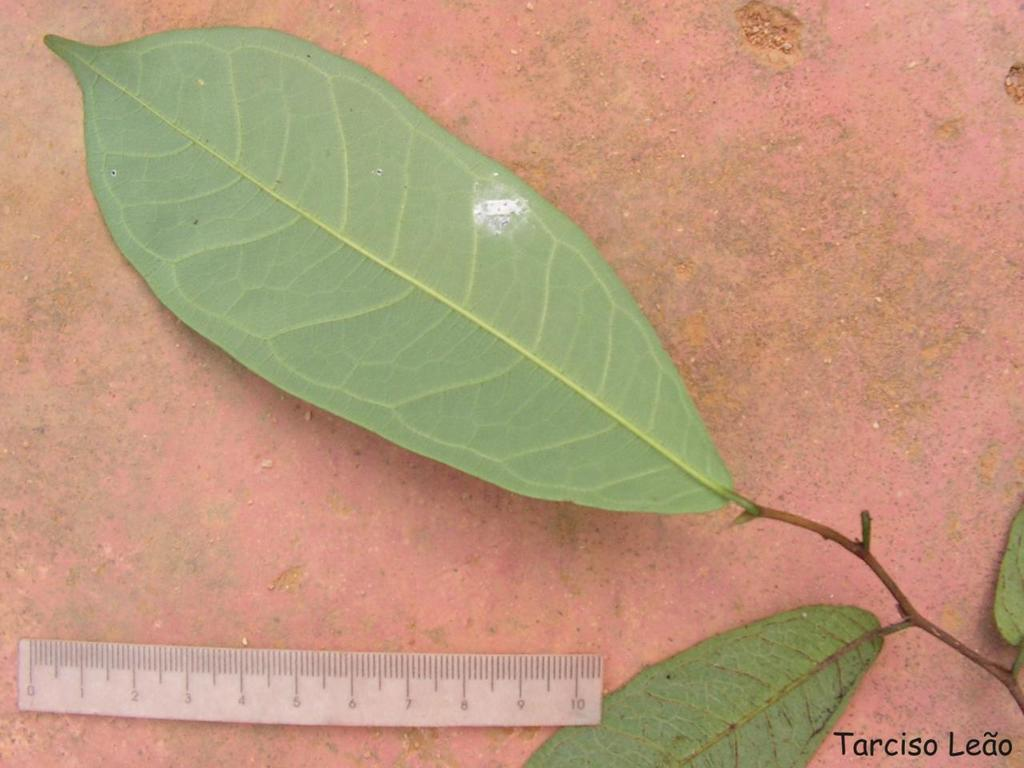<image>
Give a short and clear explanation of the subsequent image. The leaf pictured above the ruler better not be too long, as the ruler only goes up to 10cm. 